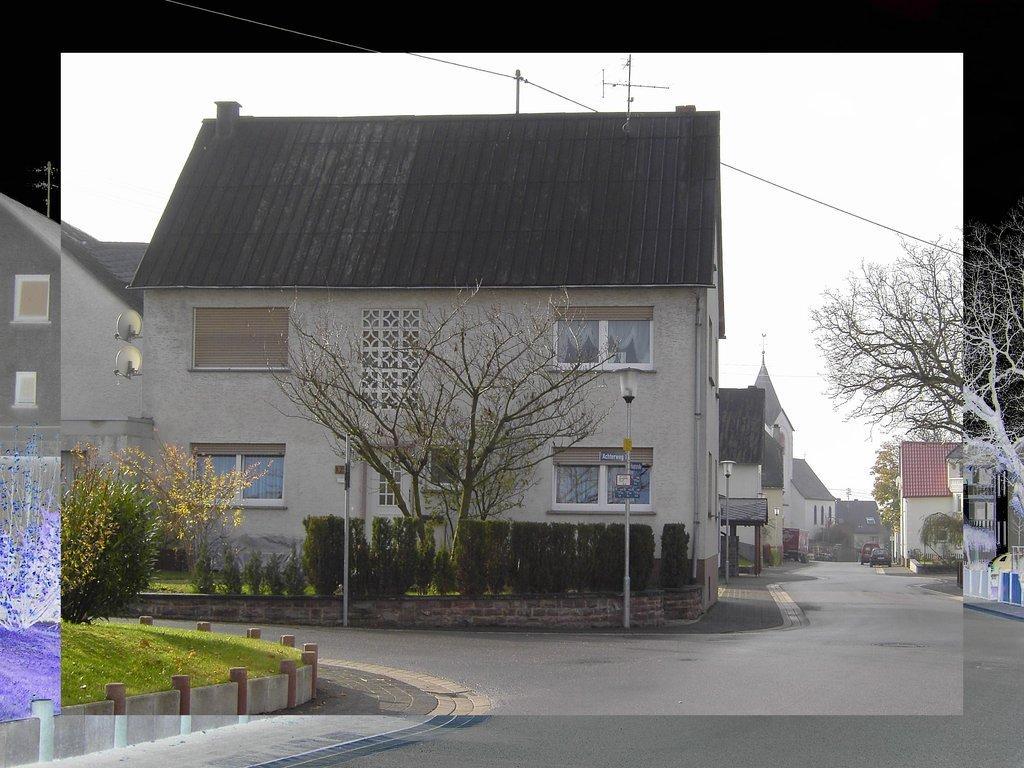How would you summarize this image in a sentence or two? This picture seems to be an edited image. In the center we can see the houses and we can see the dry stems, lampposts, plants and the vehicles. On the left we can see the green grass, plants and in the background we can see the sky, cable, metal rods and some other items. On the right corner we can see the dry stems. 